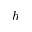<formula> <loc_0><loc_0><loc_500><loc_500>h</formula> 